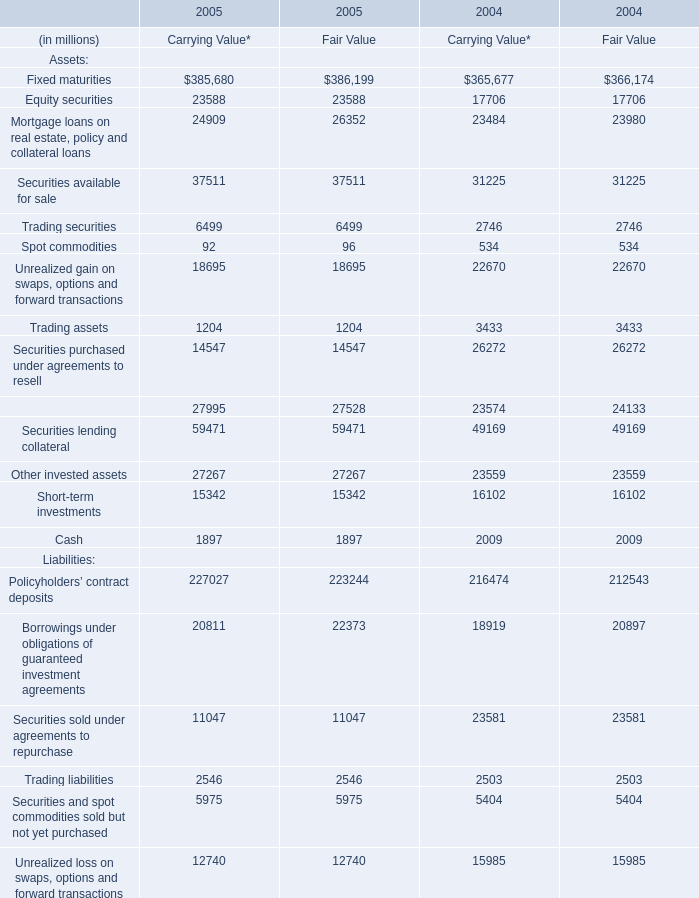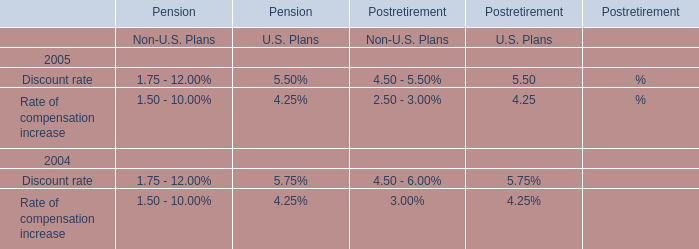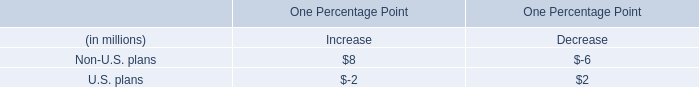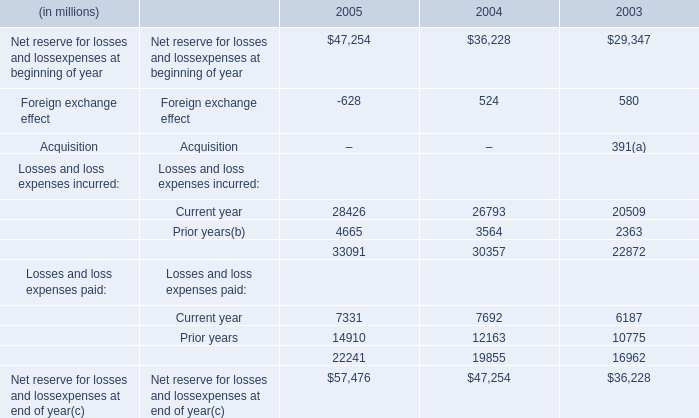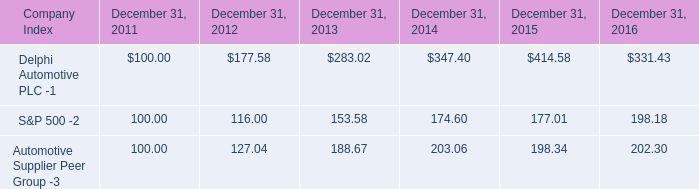If Fixed maturities of Fair Value develops with the same increasing rate in 2005, what will it reach in 2006? (in dollars in millions) 
Computations: (386199 * (1 + ((386199 - 366174) / 366174)))
Answer: 407319.1095. 